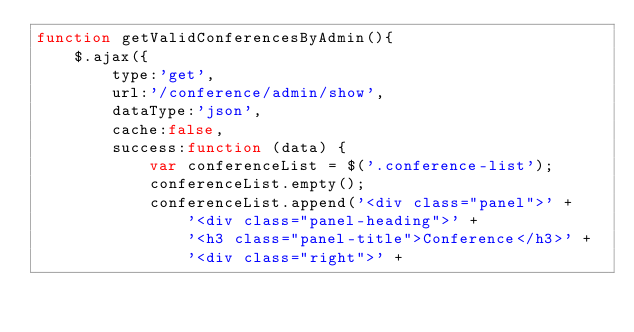Convert code to text. <code><loc_0><loc_0><loc_500><loc_500><_JavaScript_>function getValidConferencesByAdmin(){
    $.ajax({
        type:'get',
        url:'/conference/admin/show',
        dataType:'json',
        cache:false,
        success:function (data) {
            var conferenceList = $('.conference-list');
            conferenceList.empty();
            conferenceList.append('<div class="panel">' +
                '<div class="panel-heading">' +
                '<h3 class="panel-title">Conference</h3>' +
                '<div class="right">' +</code> 